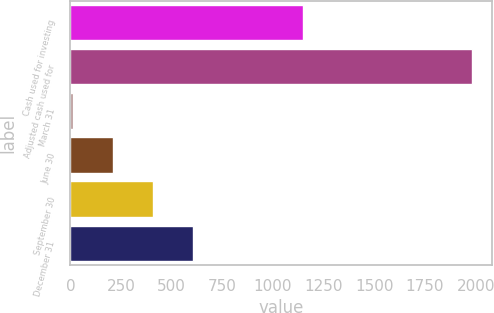Convert chart. <chart><loc_0><loc_0><loc_500><loc_500><bar_chart><fcel>Cash used for investing<fcel>Adjusted cash used for<fcel>March 31<fcel>June 30<fcel>September 30<fcel>December 31<nl><fcel>1150.1<fcel>1981.9<fcel>12.5<fcel>209.44<fcel>406.38<fcel>603.32<nl></chart> 